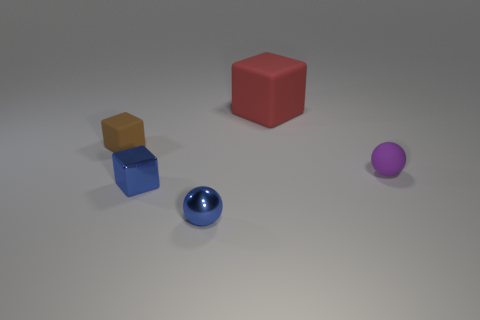Is there any other thing that is the same size as the red matte cube?
Offer a terse response. No. Is the number of tiny rubber things that are in front of the big cube the same as the number of small spheres behind the blue ball?
Provide a succinct answer. No. What number of objects are big green metallic cubes or tiny things to the left of the purple matte sphere?
Your answer should be very brief. 3. The rubber thing that is on the right side of the brown cube and left of the small purple ball has what shape?
Your answer should be compact. Cube. What is the material of the small object that is on the right side of the tiny blue thing that is in front of the blue block?
Offer a terse response. Rubber. Does the brown object that is in front of the red object have the same material as the blue cube?
Offer a very short reply. No. What size is the sphere on the left side of the red cube?
Provide a succinct answer. Small. There is a sphere that is left of the purple rubber ball; are there any tiny blue metal things that are in front of it?
Provide a short and direct response. No. There is a small rubber object to the left of the metallic cube; is it the same color as the ball in front of the purple sphere?
Your answer should be very brief. No. What color is the large matte thing?
Your answer should be compact. Red. 